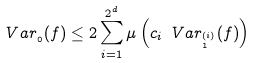Convert formula to latex. <formula><loc_0><loc_0><loc_500><loc_500>\ V a r _ { \L _ { 0 } } ( f ) \leq 2 \sum _ { i = 1 } ^ { 2 ^ { d } } \mu \left ( c _ { i } \ V a r _ { \L _ { 1 } ^ { ( i ) } } ( f ) \right )</formula> 